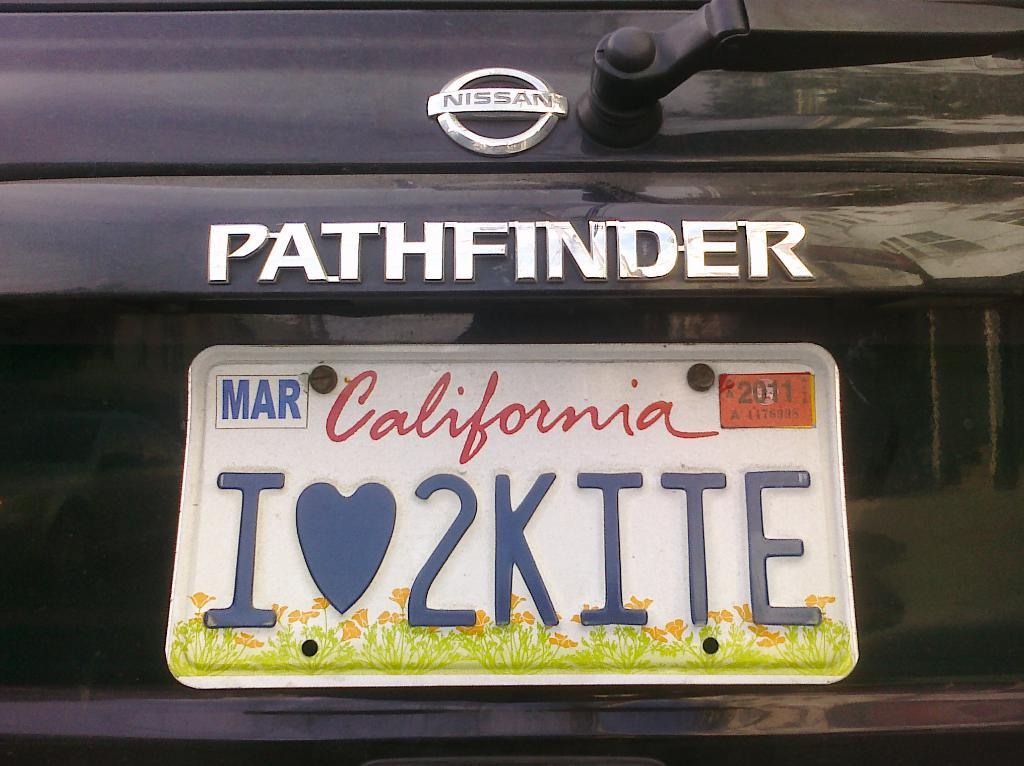<image>
Summarize the visual content of the image. A black Nissan says Pathfinder on the back above the license plate. 